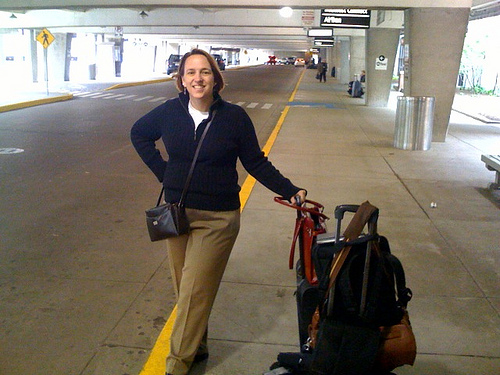Imagine the woman is a character in an adventurous story. What might be her next steps after leaving the terminal? In an adventurous story, the woman might exit the terminal to find herself swept into a thrilling chase to recover a lost artifact. Perhaps she meets a mysterious figure outside who hands her a cryptic map, leading her to mount a grand adventure filled with danger and discovery. What kind of adventure do you think she would embark on, short or long? Given the determined look on her face and her readiness for travel, she could embark on a lengthy and epic journey. Picture her traversing across continents, uncovering ancient secrets, and meeting various allies and foes along the way. Her journey could span weeks or even months as she delves into the heart of a historical mystery. 